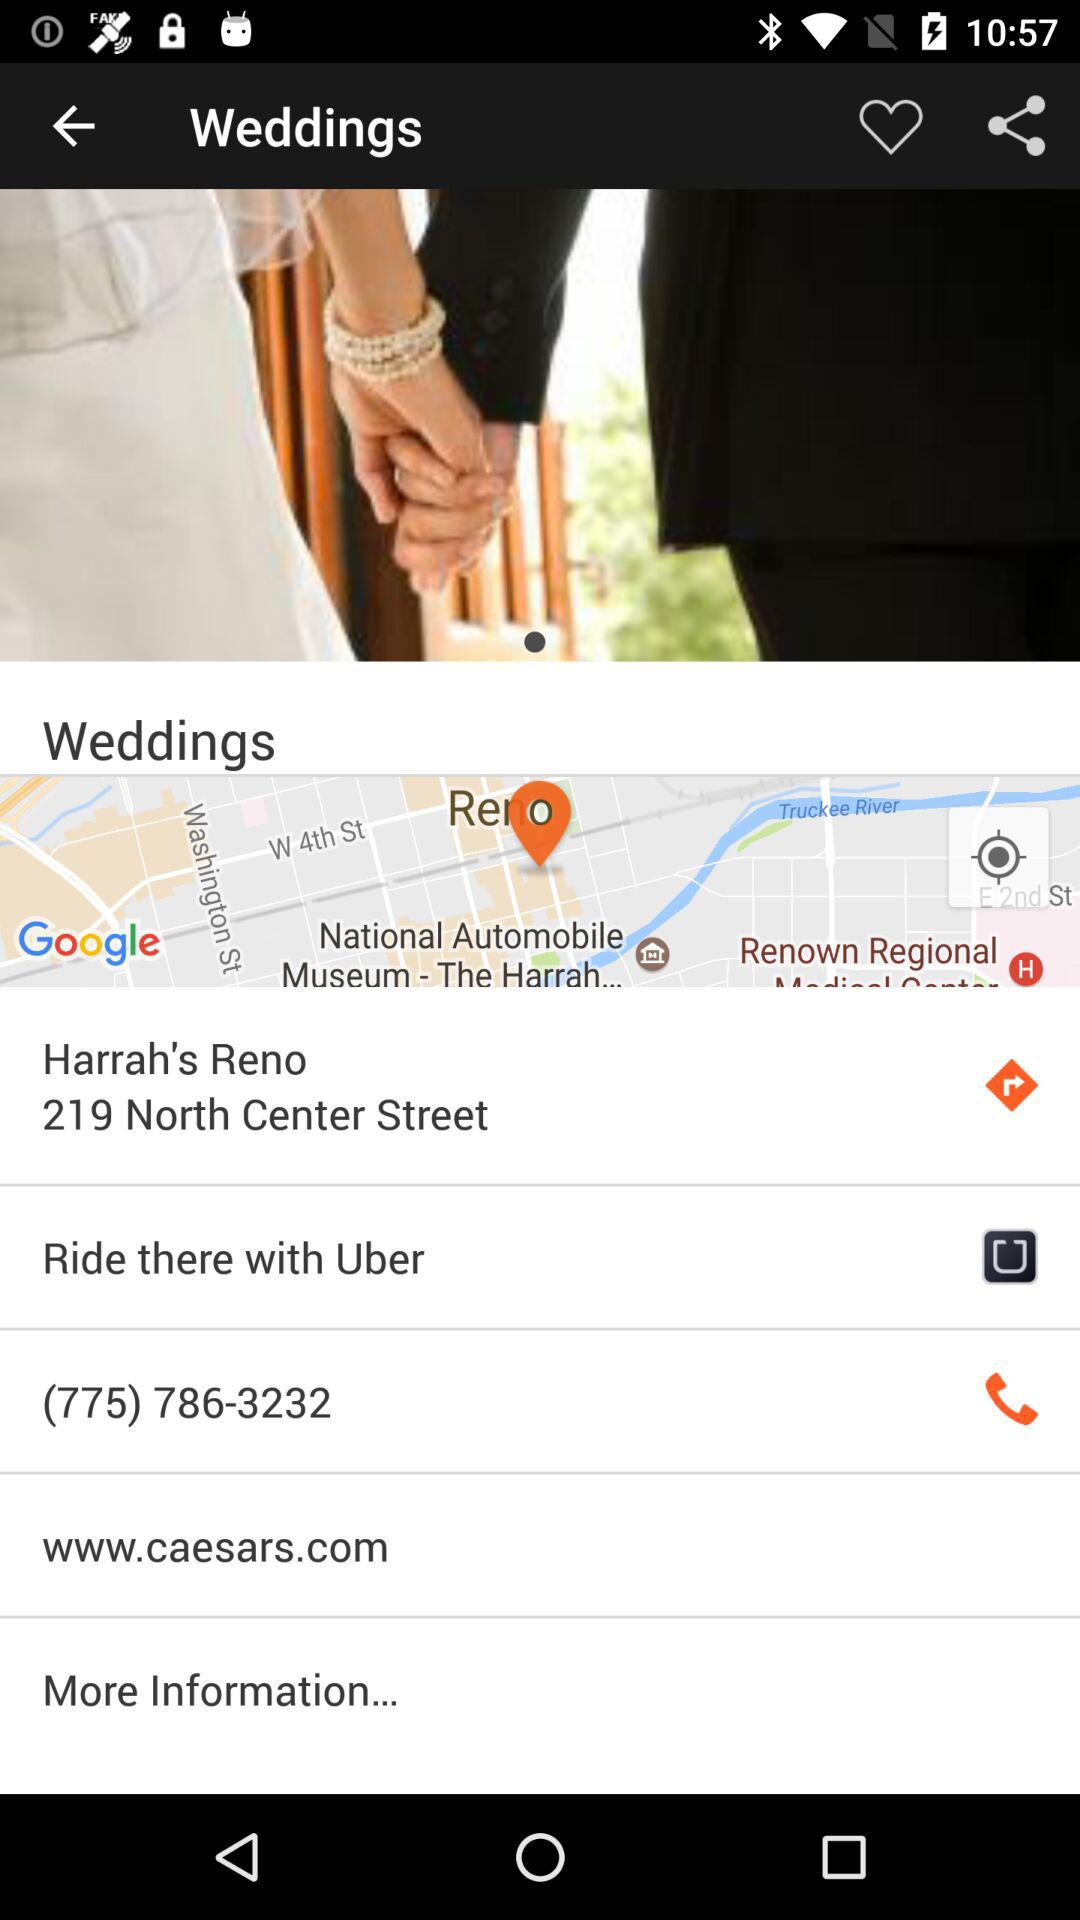What are the riding options?
When the provided information is insufficient, respond with <no answer>. <no answer> 